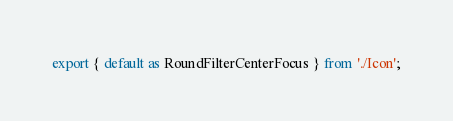Convert code to text. <code><loc_0><loc_0><loc_500><loc_500><_TypeScript_>export { default as RoundFilterCenterFocus } from './Icon';
</code> 